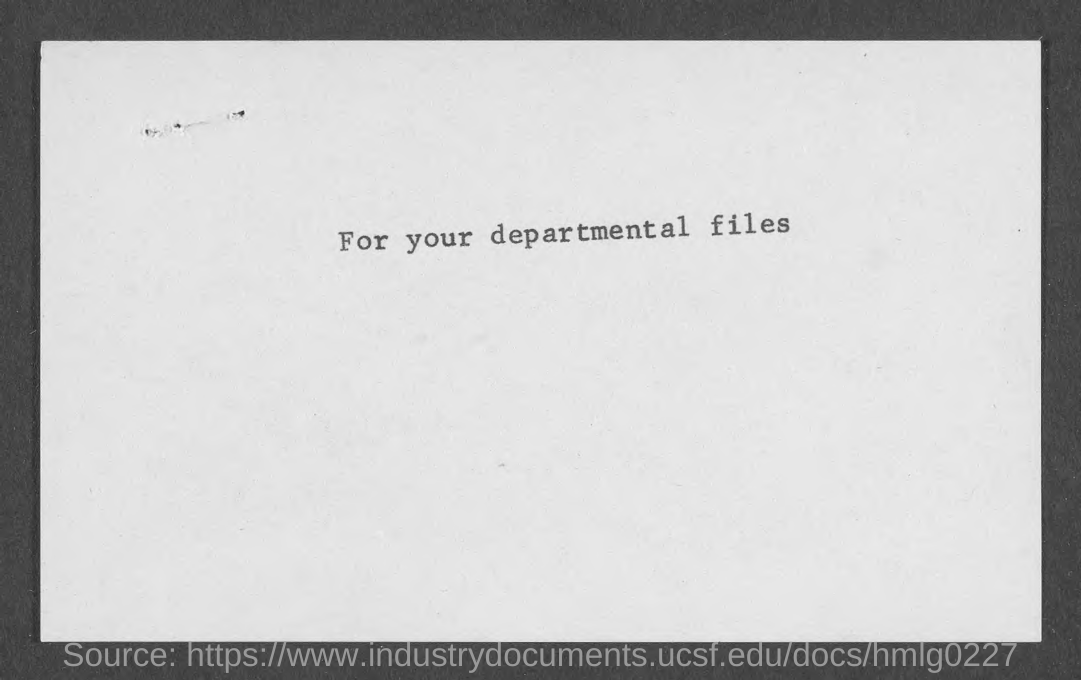What is the text on the document?
Offer a terse response. For your departmental files. 